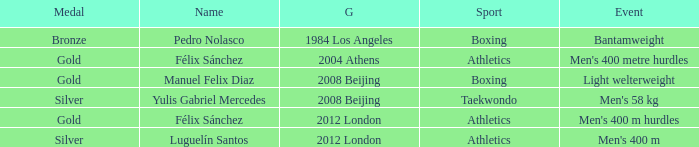Which Name had a Games of 2008 beijing, and a Medal of gold? Manuel Felix Diaz. 